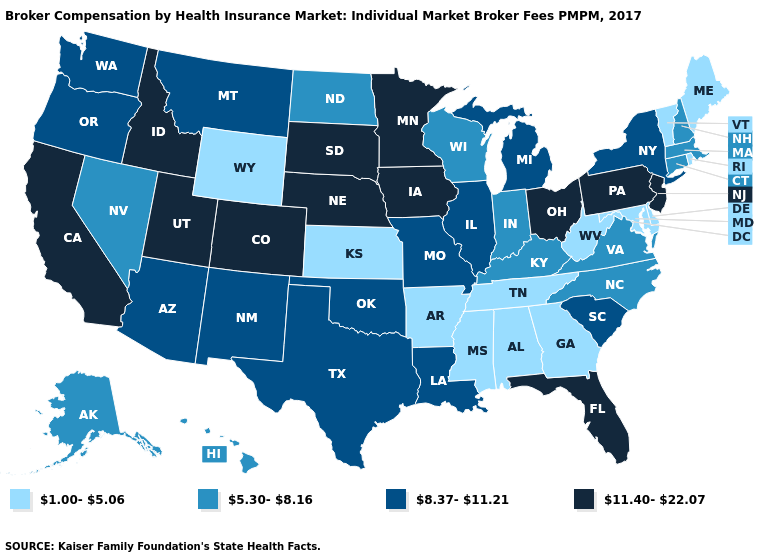What is the value of Louisiana?
Keep it brief. 8.37-11.21. Which states hav the highest value in the West?
Keep it brief. California, Colorado, Idaho, Utah. What is the value of New Jersey?
Quick response, please. 11.40-22.07. Name the states that have a value in the range 8.37-11.21?
Answer briefly. Arizona, Illinois, Louisiana, Michigan, Missouri, Montana, New Mexico, New York, Oklahoma, Oregon, South Carolina, Texas, Washington. Does Pennsylvania have the highest value in the USA?
Give a very brief answer. Yes. Name the states that have a value in the range 1.00-5.06?
Concise answer only. Alabama, Arkansas, Delaware, Georgia, Kansas, Maine, Maryland, Mississippi, Rhode Island, Tennessee, Vermont, West Virginia, Wyoming. What is the highest value in the USA?
Give a very brief answer. 11.40-22.07. What is the value of Idaho?
Quick response, please. 11.40-22.07. What is the lowest value in the Northeast?
Keep it brief. 1.00-5.06. Name the states that have a value in the range 1.00-5.06?
Write a very short answer. Alabama, Arkansas, Delaware, Georgia, Kansas, Maine, Maryland, Mississippi, Rhode Island, Tennessee, Vermont, West Virginia, Wyoming. What is the lowest value in the USA?
Keep it brief. 1.00-5.06. Name the states that have a value in the range 1.00-5.06?
Short answer required. Alabama, Arkansas, Delaware, Georgia, Kansas, Maine, Maryland, Mississippi, Rhode Island, Tennessee, Vermont, West Virginia, Wyoming. What is the lowest value in the USA?
Answer briefly. 1.00-5.06. Which states have the lowest value in the USA?
Be succinct. Alabama, Arkansas, Delaware, Georgia, Kansas, Maine, Maryland, Mississippi, Rhode Island, Tennessee, Vermont, West Virginia, Wyoming. What is the highest value in states that border Arkansas?
Be succinct. 8.37-11.21. 